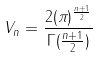<formula> <loc_0><loc_0><loc_500><loc_500>V _ { n } = \frac { 2 ( \pi ) ^ { \frac { n + 1 } { 2 } } } { \Gamma ( \frac { n + 1 } { 2 } ) }</formula> 